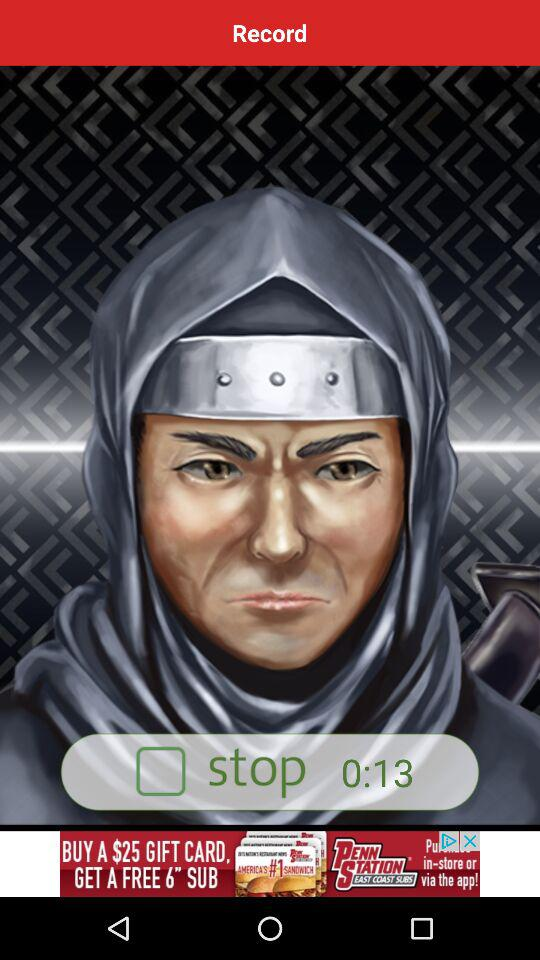What is the status of "stop"? The status is "off". 